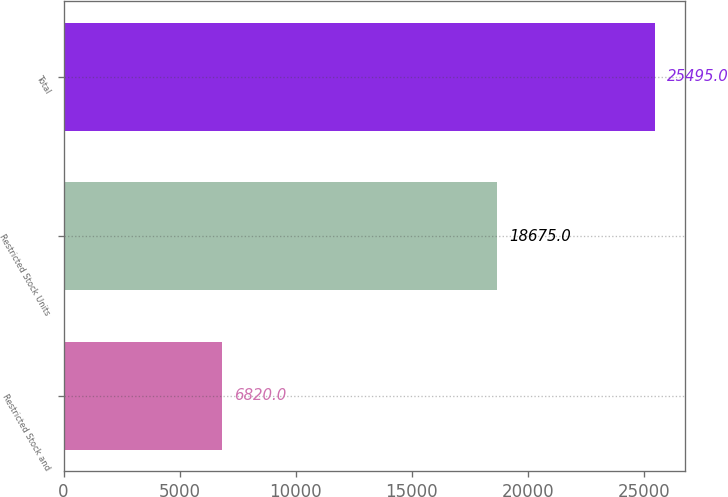Convert chart to OTSL. <chart><loc_0><loc_0><loc_500><loc_500><bar_chart><fcel>Restricted Stock and<fcel>Restricted Stock Units<fcel>Total<nl><fcel>6820<fcel>18675<fcel>25495<nl></chart> 